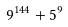<formula> <loc_0><loc_0><loc_500><loc_500>9 ^ { 1 4 4 } + 5 ^ { 9 }</formula> 